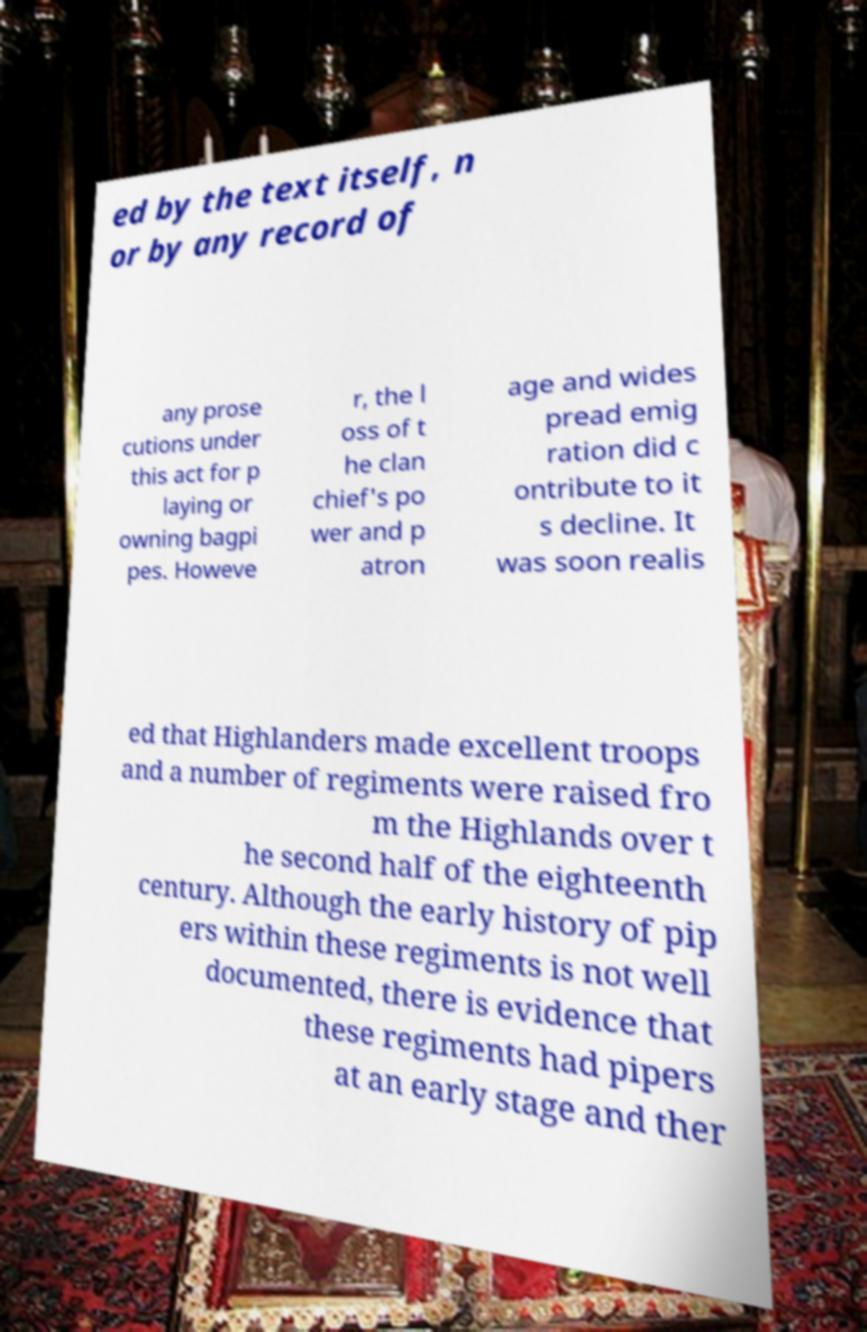There's text embedded in this image that I need extracted. Can you transcribe it verbatim? ed by the text itself, n or by any record of any prose cutions under this act for p laying or owning bagpi pes. Howeve r, the l oss of t he clan chief's po wer and p atron age and wides pread emig ration did c ontribute to it s decline. It was soon realis ed that Highlanders made excellent troops and a number of regiments were raised fro m the Highlands over t he second half of the eighteenth century. Although the early history of pip ers within these regiments is not well documented, there is evidence that these regiments had pipers at an early stage and ther 